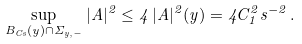<formula> <loc_0><loc_0><loc_500><loc_500>\sup _ { B _ { C s } ( y ) \cap \Sigma _ { y , - } } | A | ^ { 2 } \leq 4 \, | A | ^ { 2 } ( y ) = 4 C _ { 1 } ^ { 2 } s ^ { - 2 } \, .</formula> 